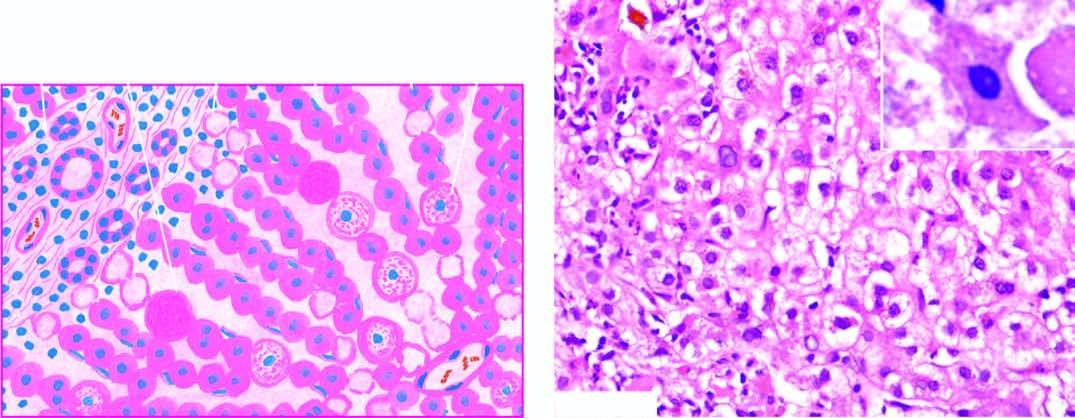what is seen as ballooning degeneration while acidophilic councilman bodies are indicative of more severe liver cell injury?
Answer the question using a single word or phrase. Mild degree of liver cell necrosis 